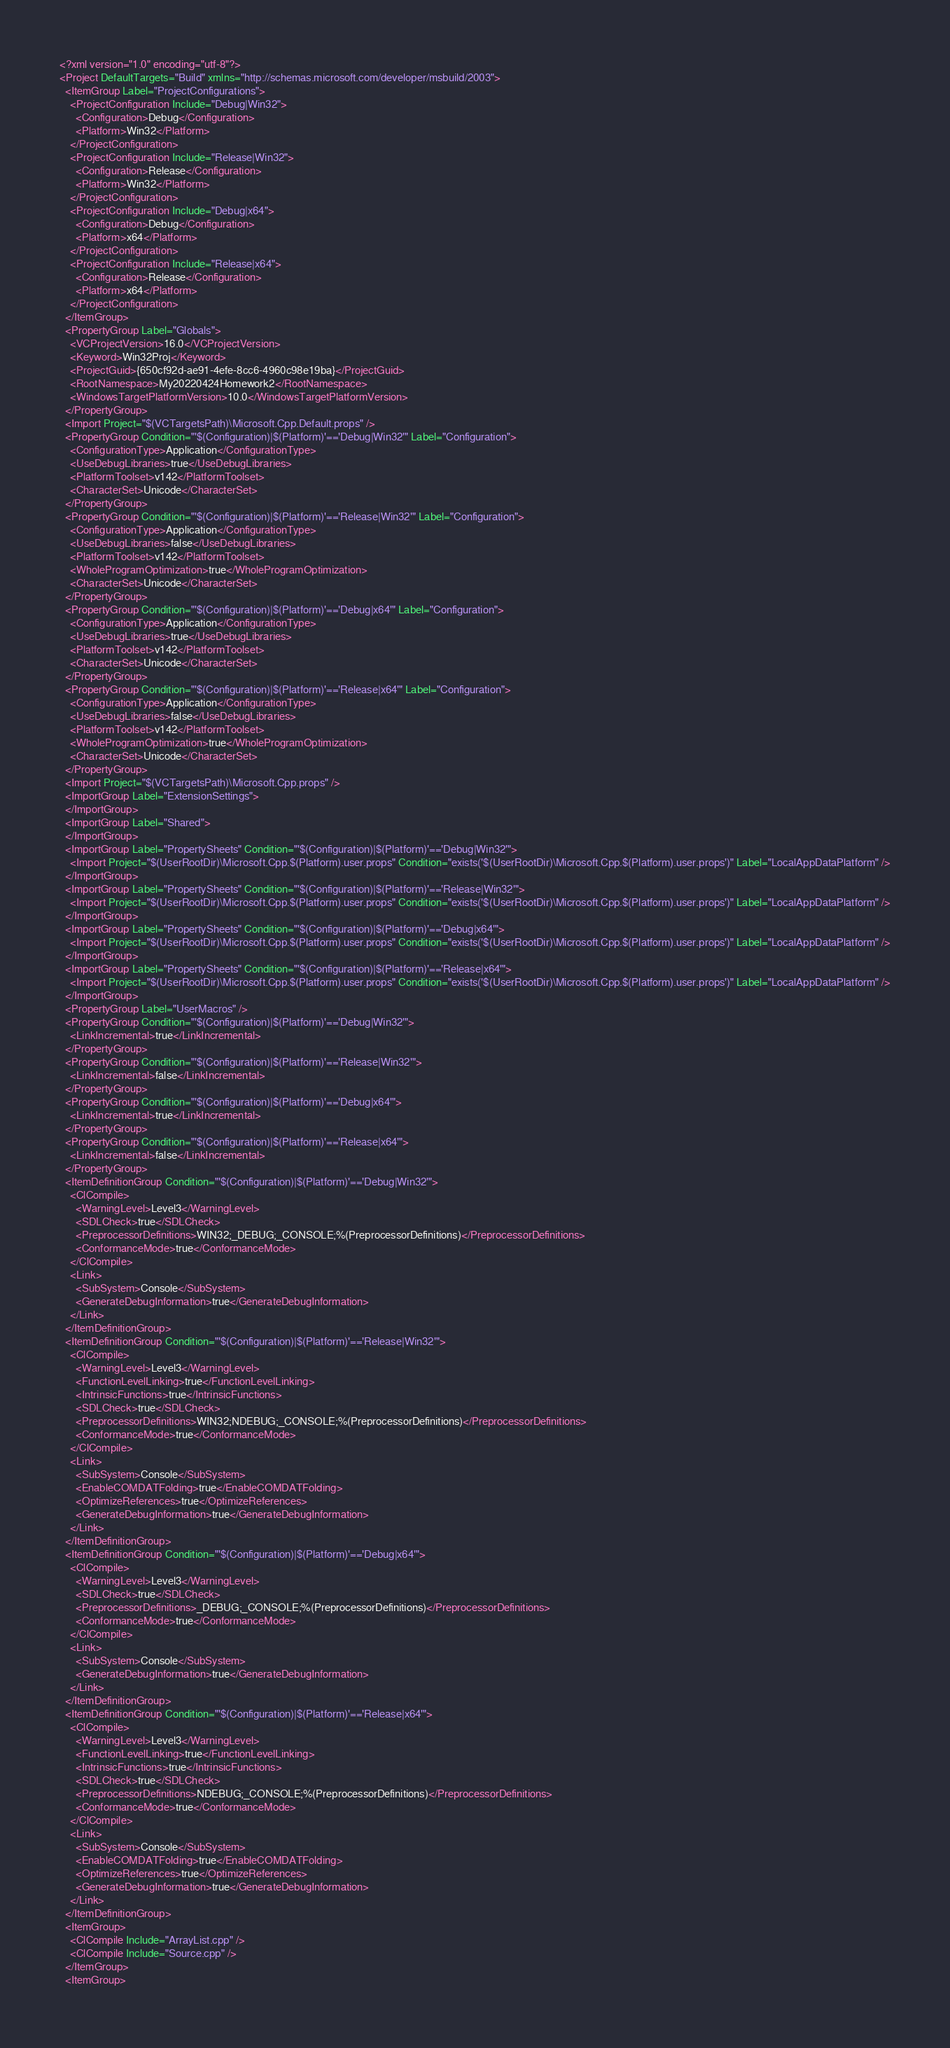Convert code to text. <code><loc_0><loc_0><loc_500><loc_500><_XML_><?xml version="1.0" encoding="utf-8"?>
<Project DefaultTargets="Build" xmlns="http://schemas.microsoft.com/developer/msbuild/2003">
  <ItemGroup Label="ProjectConfigurations">
    <ProjectConfiguration Include="Debug|Win32">
      <Configuration>Debug</Configuration>
      <Platform>Win32</Platform>
    </ProjectConfiguration>
    <ProjectConfiguration Include="Release|Win32">
      <Configuration>Release</Configuration>
      <Platform>Win32</Platform>
    </ProjectConfiguration>
    <ProjectConfiguration Include="Debug|x64">
      <Configuration>Debug</Configuration>
      <Platform>x64</Platform>
    </ProjectConfiguration>
    <ProjectConfiguration Include="Release|x64">
      <Configuration>Release</Configuration>
      <Platform>x64</Platform>
    </ProjectConfiguration>
  </ItemGroup>
  <PropertyGroup Label="Globals">
    <VCProjectVersion>16.0</VCProjectVersion>
    <Keyword>Win32Proj</Keyword>
    <ProjectGuid>{650cf92d-ae91-4efe-8cc6-4960c98e19ba}</ProjectGuid>
    <RootNamespace>My20220424Homework2</RootNamespace>
    <WindowsTargetPlatformVersion>10.0</WindowsTargetPlatformVersion>
  </PropertyGroup>
  <Import Project="$(VCTargetsPath)\Microsoft.Cpp.Default.props" />
  <PropertyGroup Condition="'$(Configuration)|$(Platform)'=='Debug|Win32'" Label="Configuration">
    <ConfigurationType>Application</ConfigurationType>
    <UseDebugLibraries>true</UseDebugLibraries>
    <PlatformToolset>v142</PlatformToolset>
    <CharacterSet>Unicode</CharacterSet>
  </PropertyGroup>
  <PropertyGroup Condition="'$(Configuration)|$(Platform)'=='Release|Win32'" Label="Configuration">
    <ConfigurationType>Application</ConfigurationType>
    <UseDebugLibraries>false</UseDebugLibraries>
    <PlatformToolset>v142</PlatformToolset>
    <WholeProgramOptimization>true</WholeProgramOptimization>
    <CharacterSet>Unicode</CharacterSet>
  </PropertyGroup>
  <PropertyGroup Condition="'$(Configuration)|$(Platform)'=='Debug|x64'" Label="Configuration">
    <ConfigurationType>Application</ConfigurationType>
    <UseDebugLibraries>true</UseDebugLibraries>
    <PlatformToolset>v142</PlatformToolset>
    <CharacterSet>Unicode</CharacterSet>
  </PropertyGroup>
  <PropertyGroup Condition="'$(Configuration)|$(Platform)'=='Release|x64'" Label="Configuration">
    <ConfigurationType>Application</ConfigurationType>
    <UseDebugLibraries>false</UseDebugLibraries>
    <PlatformToolset>v142</PlatformToolset>
    <WholeProgramOptimization>true</WholeProgramOptimization>
    <CharacterSet>Unicode</CharacterSet>
  </PropertyGroup>
  <Import Project="$(VCTargetsPath)\Microsoft.Cpp.props" />
  <ImportGroup Label="ExtensionSettings">
  </ImportGroup>
  <ImportGroup Label="Shared">
  </ImportGroup>
  <ImportGroup Label="PropertySheets" Condition="'$(Configuration)|$(Platform)'=='Debug|Win32'">
    <Import Project="$(UserRootDir)\Microsoft.Cpp.$(Platform).user.props" Condition="exists('$(UserRootDir)\Microsoft.Cpp.$(Platform).user.props')" Label="LocalAppDataPlatform" />
  </ImportGroup>
  <ImportGroup Label="PropertySheets" Condition="'$(Configuration)|$(Platform)'=='Release|Win32'">
    <Import Project="$(UserRootDir)\Microsoft.Cpp.$(Platform).user.props" Condition="exists('$(UserRootDir)\Microsoft.Cpp.$(Platform).user.props')" Label="LocalAppDataPlatform" />
  </ImportGroup>
  <ImportGroup Label="PropertySheets" Condition="'$(Configuration)|$(Platform)'=='Debug|x64'">
    <Import Project="$(UserRootDir)\Microsoft.Cpp.$(Platform).user.props" Condition="exists('$(UserRootDir)\Microsoft.Cpp.$(Platform).user.props')" Label="LocalAppDataPlatform" />
  </ImportGroup>
  <ImportGroup Label="PropertySheets" Condition="'$(Configuration)|$(Platform)'=='Release|x64'">
    <Import Project="$(UserRootDir)\Microsoft.Cpp.$(Platform).user.props" Condition="exists('$(UserRootDir)\Microsoft.Cpp.$(Platform).user.props')" Label="LocalAppDataPlatform" />
  </ImportGroup>
  <PropertyGroup Label="UserMacros" />
  <PropertyGroup Condition="'$(Configuration)|$(Platform)'=='Debug|Win32'">
    <LinkIncremental>true</LinkIncremental>
  </PropertyGroup>
  <PropertyGroup Condition="'$(Configuration)|$(Platform)'=='Release|Win32'">
    <LinkIncremental>false</LinkIncremental>
  </PropertyGroup>
  <PropertyGroup Condition="'$(Configuration)|$(Platform)'=='Debug|x64'">
    <LinkIncremental>true</LinkIncremental>
  </PropertyGroup>
  <PropertyGroup Condition="'$(Configuration)|$(Platform)'=='Release|x64'">
    <LinkIncremental>false</LinkIncremental>
  </PropertyGroup>
  <ItemDefinitionGroup Condition="'$(Configuration)|$(Platform)'=='Debug|Win32'">
    <ClCompile>
      <WarningLevel>Level3</WarningLevel>
      <SDLCheck>true</SDLCheck>
      <PreprocessorDefinitions>WIN32;_DEBUG;_CONSOLE;%(PreprocessorDefinitions)</PreprocessorDefinitions>
      <ConformanceMode>true</ConformanceMode>
    </ClCompile>
    <Link>
      <SubSystem>Console</SubSystem>
      <GenerateDebugInformation>true</GenerateDebugInformation>
    </Link>
  </ItemDefinitionGroup>
  <ItemDefinitionGroup Condition="'$(Configuration)|$(Platform)'=='Release|Win32'">
    <ClCompile>
      <WarningLevel>Level3</WarningLevel>
      <FunctionLevelLinking>true</FunctionLevelLinking>
      <IntrinsicFunctions>true</IntrinsicFunctions>
      <SDLCheck>true</SDLCheck>
      <PreprocessorDefinitions>WIN32;NDEBUG;_CONSOLE;%(PreprocessorDefinitions)</PreprocessorDefinitions>
      <ConformanceMode>true</ConformanceMode>
    </ClCompile>
    <Link>
      <SubSystem>Console</SubSystem>
      <EnableCOMDATFolding>true</EnableCOMDATFolding>
      <OptimizeReferences>true</OptimizeReferences>
      <GenerateDebugInformation>true</GenerateDebugInformation>
    </Link>
  </ItemDefinitionGroup>
  <ItemDefinitionGroup Condition="'$(Configuration)|$(Platform)'=='Debug|x64'">
    <ClCompile>
      <WarningLevel>Level3</WarningLevel>
      <SDLCheck>true</SDLCheck>
      <PreprocessorDefinitions>_DEBUG;_CONSOLE;%(PreprocessorDefinitions)</PreprocessorDefinitions>
      <ConformanceMode>true</ConformanceMode>
    </ClCompile>
    <Link>
      <SubSystem>Console</SubSystem>
      <GenerateDebugInformation>true</GenerateDebugInformation>
    </Link>
  </ItemDefinitionGroup>
  <ItemDefinitionGroup Condition="'$(Configuration)|$(Platform)'=='Release|x64'">
    <ClCompile>
      <WarningLevel>Level3</WarningLevel>
      <FunctionLevelLinking>true</FunctionLevelLinking>
      <IntrinsicFunctions>true</IntrinsicFunctions>
      <SDLCheck>true</SDLCheck>
      <PreprocessorDefinitions>NDEBUG;_CONSOLE;%(PreprocessorDefinitions)</PreprocessorDefinitions>
      <ConformanceMode>true</ConformanceMode>
    </ClCompile>
    <Link>
      <SubSystem>Console</SubSystem>
      <EnableCOMDATFolding>true</EnableCOMDATFolding>
      <OptimizeReferences>true</OptimizeReferences>
      <GenerateDebugInformation>true</GenerateDebugInformation>
    </Link>
  </ItemDefinitionGroup>
  <ItemGroup>
    <ClCompile Include="ArrayList.cpp" />
    <ClCompile Include="Source.cpp" />
  </ItemGroup>
  <ItemGroup></code> 